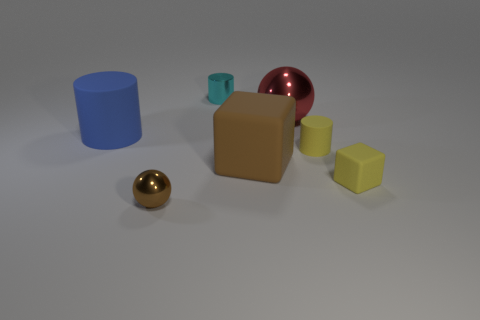What number of yellow objects are the same size as the blue rubber thing?
Offer a very short reply. 0. There is a tiny cyan object; what shape is it?
Provide a short and direct response. Cylinder. What is the size of the metal object that is left of the big shiny object and behind the small brown metal ball?
Your response must be concise. Small. There is a brown thing that is behind the brown metallic object; what is it made of?
Provide a succinct answer. Rubber. Is the color of the big matte block the same as the big thing behind the big blue cylinder?
Offer a terse response. No. How many objects are either yellow matte objects behind the large brown rubber thing or large things in front of the large blue matte object?
Offer a terse response. 2. The matte object that is both left of the yellow cube and right of the brown matte cube is what color?
Your answer should be compact. Yellow. Are there more brown shiny things than big cyan blocks?
Ensure brevity in your answer.  Yes. Is the shape of the large object that is on the left side of the tiny cyan thing the same as  the large shiny object?
Provide a short and direct response. No. How many rubber things are either large blue cylinders or yellow objects?
Your answer should be very brief. 3. 